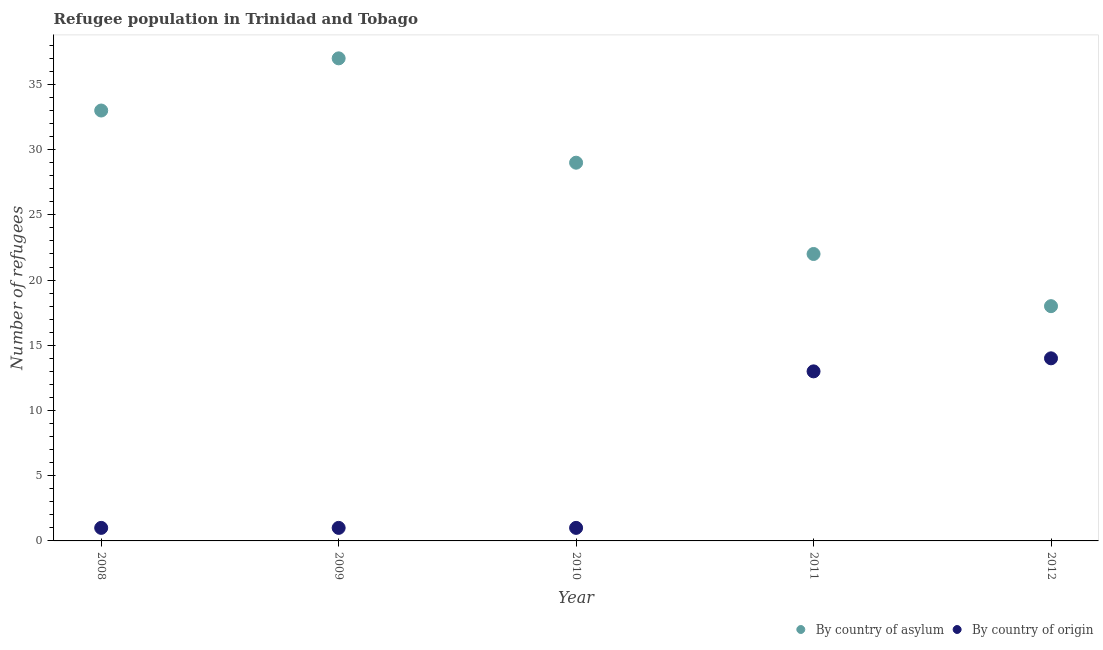How many different coloured dotlines are there?
Provide a short and direct response. 2. What is the number of refugees by country of origin in 2012?
Your answer should be compact. 14. Across all years, what is the maximum number of refugees by country of origin?
Your answer should be compact. 14. Across all years, what is the minimum number of refugees by country of asylum?
Offer a very short reply. 18. In which year was the number of refugees by country of asylum minimum?
Your response must be concise. 2012. What is the total number of refugees by country of origin in the graph?
Your response must be concise. 30. What is the difference between the number of refugees by country of asylum in 2010 and that in 2011?
Your answer should be compact. 7. What is the difference between the number of refugees by country of origin in 2012 and the number of refugees by country of asylum in 2008?
Give a very brief answer. -19. In the year 2012, what is the difference between the number of refugees by country of origin and number of refugees by country of asylum?
Your response must be concise. -4. In how many years, is the number of refugees by country of asylum greater than 8?
Provide a short and direct response. 5. What is the ratio of the number of refugees by country of origin in 2009 to that in 2012?
Your response must be concise. 0.07. Is the number of refugees by country of origin in 2009 less than that in 2012?
Offer a very short reply. Yes. Is the difference between the number of refugees by country of asylum in 2011 and 2012 greater than the difference between the number of refugees by country of origin in 2011 and 2012?
Your response must be concise. Yes. What is the difference between the highest and the lowest number of refugees by country of origin?
Your answer should be compact. 13. Is the sum of the number of refugees by country of asylum in 2009 and 2011 greater than the maximum number of refugees by country of origin across all years?
Provide a short and direct response. Yes. Is the number of refugees by country of asylum strictly greater than the number of refugees by country of origin over the years?
Keep it short and to the point. Yes. Is the number of refugees by country of origin strictly less than the number of refugees by country of asylum over the years?
Ensure brevity in your answer.  Yes. What is the difference between two consecutive major ticks on the Y-axis?
Your answer should be very brief. 5. Does the graph contain any zero values?
Keep it short and to the point. No. How many legend labels are there?
Give a very brief answer. 2. How are the legend labels stacked?
Offer a terse response. Horizontal. What is the title of the graph?
Your answer should be very brief. Refugee population in Trinidad and Tobago. Does "Revenue" appear as one of the legend labels in the graph?
Your answer should be compact. No. What is the label or title of the X-axis?
Provide a short and direct response. Year. What is the label or title of the Y-axis?
Offer a very short reply. Number of refugees. What is the Number of refugees in By country of origin in 2008?
Keep it short and to the point. 1. What is the Number of refugees of By country of asylum in 2009?
Offer a terse response. 37. What is the Number of refugees of By country of asylum in 2010?
Keep it short and to the point. 29. What is the Number of refugees in By country of origin in 2010?
Your answer should be compact. 1. What is the Number of refugees of By country of origin in 2011?
Provide a succinct answer. 13. What is the Number of refugees in By country of asylum in 2012?
Your response must be concise. 18. Across all years, what is the maximum Number of refugees of By country of asylum?
Ensure brevity in your answer.  37. Across all years, what is the maximum Number of refugees in By country of origin?
Your answer should be compact. 14. What is the total Number of refugees of By country of asylum in the graph?
Your response must be concise. 139. What is the total Number of refugees of By country of origin in the graph?
Your response must be concise. 30. What is the difference between the Number of refugees of By country of asylum in 2008 and that in 2009?
Your response must be concise. -4. What is the difference between the Number of refugees in By country of origin in 2008 and that in 2009?
Your answer should be very brief. 0. What is the difference between the Number of refugees of By country of asylum in 2008 and that in 2010?
Your answer should be compact. 4. What is the difference between the Number of refugees of By country of asylum in 2008 and that in 2011?
Keep it short and to the point. 11. What is the difference between the Number of refugees in By country of asylum in 2009 and that in 2010?
Give a very brief answer. 8. What is the difference between the Number of refugees of By country of asylum in 2009 and that in 2011?
Give a very brief answer. 15. What is the difference between the Number of refugees in By country of asylum in 2009 and that in 2012?
Provide a succinct answer. 19. What is the difference between the Number of refugees in By country of asylum in 2010 and that in 2011?
Your response must be concise. 7. What is the difference between the Number of refugees in By country of origin in 2010 and that in 2011?
Offer a very short reply. -12. What is the difference between the Number of refugees of By country of asylum in 2010 and that in 2012?
Make the answer very short. 11. What is the difference between the Number of refugees in By country of origin in 2010 and that in 2012?
Provide a succinct answer. -13. What is the difference between the Number of refugees of By country of asylum in 2011 and that in 2012?
Your answer should be compact. 4. What is the difference between the Number of refugees in By country of asylum in 2008 and the Number of refugees in By country of origin in 2009?
Ensure brevity in your answer.  32. What is the difference between the Number of refugees in By country of asylum in 2008 and the Number of refugees in By country of origin in 2010?
Keep it short and to the point. 32. What is the difference between the Number of refugees of By country of asylum in 2008 and the Number of refugees of By country of origin in 2011?
Provide a succinct answer. 20. What is the difference between the Number of refugees of By country of asylum in 2008 and the Number of refugees of By country of origin in 2012?
Your answer should be compact. 19. What is the difference between the Number of refugees of By country of asylum in 2009 and the Number of refugees of By country of origin in 2010?
Provide a succinct answer. 36. What is the difference between the Number of refugees in By country of asylum in 2009 and the Number of refugees in By country of origin in 2011?
Offer a terse response. 24. What is the difference between the Number of refugees of By country of asylum in 2009 and the Number of refugees of By country of origin in 2012?
Offer a very short reply. 23. What is the difference between the Number of refugees in By country of asylum in 2010 and the Number of refugees in By country of origin in 2011?
Offer a very short reply. 16. What is the average Number of refugees in By country of asylum per year?
Your answer should be very brief. 27.8. What is the average Number of refugees in By country of origin per year?
Make the answer very short. 6. In the year 2010, what is the difference between the Number of refugees of By country of asylum and Number of refugees of By country of origin?
Give a very brief answer. 28. In the year 2012, what is the difference between the Number of refugees of By country of asylum and Number of refugees of By country of origin?
Ensure brevity in your answer.  4. What is the ratio of the Number of refugees in By country of asylum in 2008 to that in 2009?
Provide a short and direct response. 0.89. What is the ratio of the Number of refugees of By country of origin in 2008 to that in 2009?
Offer a terse response. 1. What is the ratio of the Number of refugees of By country of asylum in 2008 to that in 2010?
Make the answer very short. 1.14. What is the ratio of the Number of refugees of By country of origin in 2008 to that in 2011?
Offer a terse response. 0.08. What is the ratio of the Number of refugees of By country of asylum in 2008 to that in 2012?
Keep it short and to the point. 1.83. What is the ratio of the Number of refugees in By country of origin in 2008 to that in 2012?
Your answer should be compact. 0.07. What is the ratio of the Number of refugees of By country of asylum in 2009 to that in 2010?
Ensure brevity in your answer.  1.28. What is the ratio of the Number of refugees of By country of origin in 2009 to that in 2010?
Offer a terse response. 1. What is the ratio of the Number of refugees in By country of asylum in 2009 to that in 2011?
Ensure brevity in your answer.  1.68. What is the ratio of the Number of refugees in By country of origin in 2009 to that in 2011?
Give a very brief answer. 0.08. What is the ratio of the Number of refugees in By country of asylum in 2009 to that in 2012?
Keep it short and to the point. 2.06. What is the ratio of the Number of refugees in By country of origin in 2009 to that in 2012?
Ensure brevity in your answer.  0.07. What is the ratio of the Number of refugees of By country of asylum in 2010 to that in 2011?
Give a very brief answer. 1.32. What is the ratio of the Number of refugees in By country of origin in 2010 to that in 2011?
Offer a terse response. 0.08. What is the ratio of the Number of refugees of By country of asylum in 2010 to that in 2012?
Provide a short and direct response. 1.61. What is the ratio of the Number of refugees in By country of origin in 2010 to that in 2012?
Make the answer very short. 0.07. What is the ratio of the Number of refugees of By country of asylum in 2011 to that in 2012?
Keep it short and to the point. 1.22. What is the ratio of the Number of refugees in By country of origin in 2011 to that in 2012?
Your answer should be very brief. 0.93. What is the difference between the highest and the second highest Number of refugees of By country of asylum?
Provide a succinct answer. 4. What is the difference between the highest and the lowest Number of refugees in By country of asylum?
Keep it short and to the point. 19. What is the difference between the highest and the lowest Number of refugees in By country of origin?
Offer a very short reply. 13. 